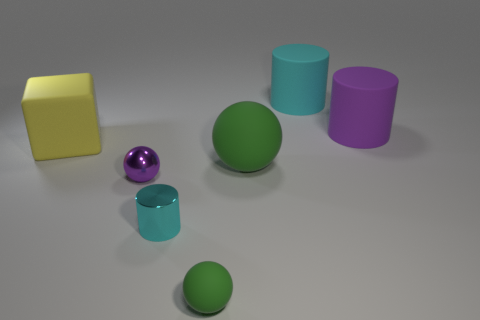What number of things are left of the matte sphere on the right side of the green matte ball in front of the purple metallic object?
Give a very brief answer. 4. There is another cyan object that is the same shape as the big cyan matte object; what is its size?
Offer a terse response. Small. Are there fewer tiny green balls to the left of the yellow matte object than tiny cyan cubes?
Provide a short and direct response. No. Is the small cyan metallic object the same shape as the large purple object?
Make the answer very short. Yes. There is a large rubber thing that is the same shape as the tiny matte object; what color is it?
Provide a succinct answer. Green. What number of matte cylinders are the same color as the big rubber ball?
Offer a very short reply. 0. What number of objects are either things behind the big green matte sphere or green objects?
Your answer should be compact. 5. There is a cyan cylinder that is behind the yellow thing; what size is it?
Provide a short and direct response. Large. Is the number of red objects less than the number of big purple rubber cylinders?
Give a very brief answer. Yes. Does the cylinder that is left of the big sphere have the same material as the cyan object that is behind the large yellow thing?
Provide a short and direct response. No. 